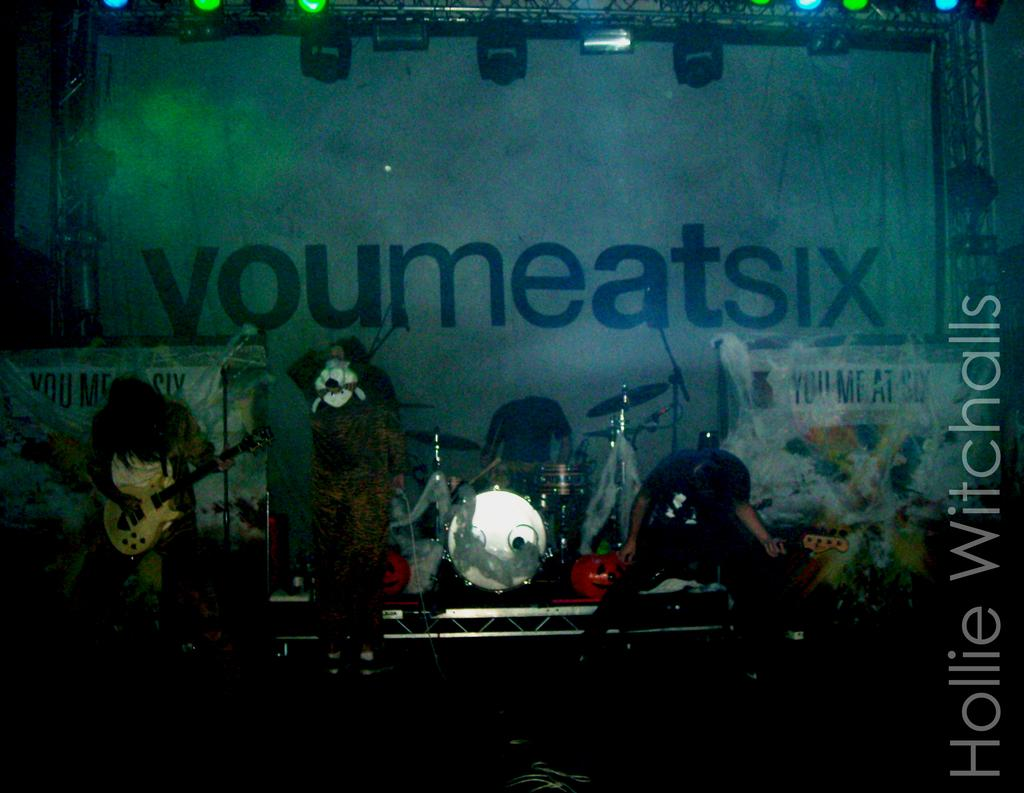What are the people in the image doing? The people in the image are standing and holding musical instruments. What can be seen on the banner in the image? There is a banner with text in the image. What type of structure is present in the image? There is a metal frame in the image. What can be used to illuminate the scene in the image? There are lights visible in the image. What type of dolls are being used in the process depicted in the image? There are no dolls present in the image, and no process is depicted. 